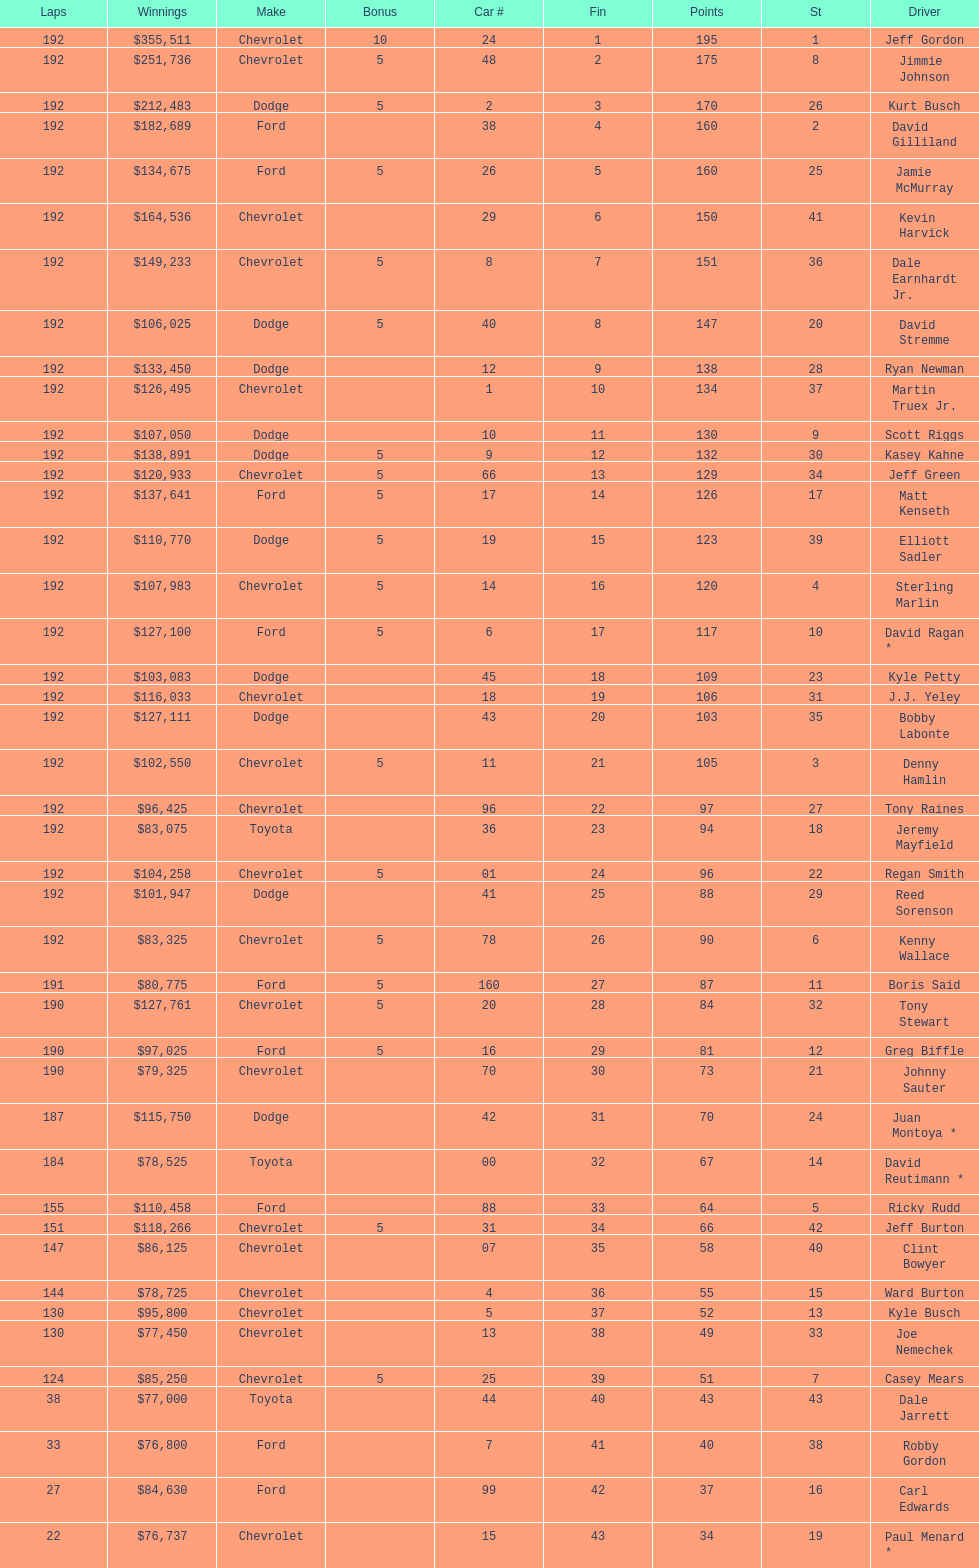How many drivers earned 5 bonus each in the race? 19. 